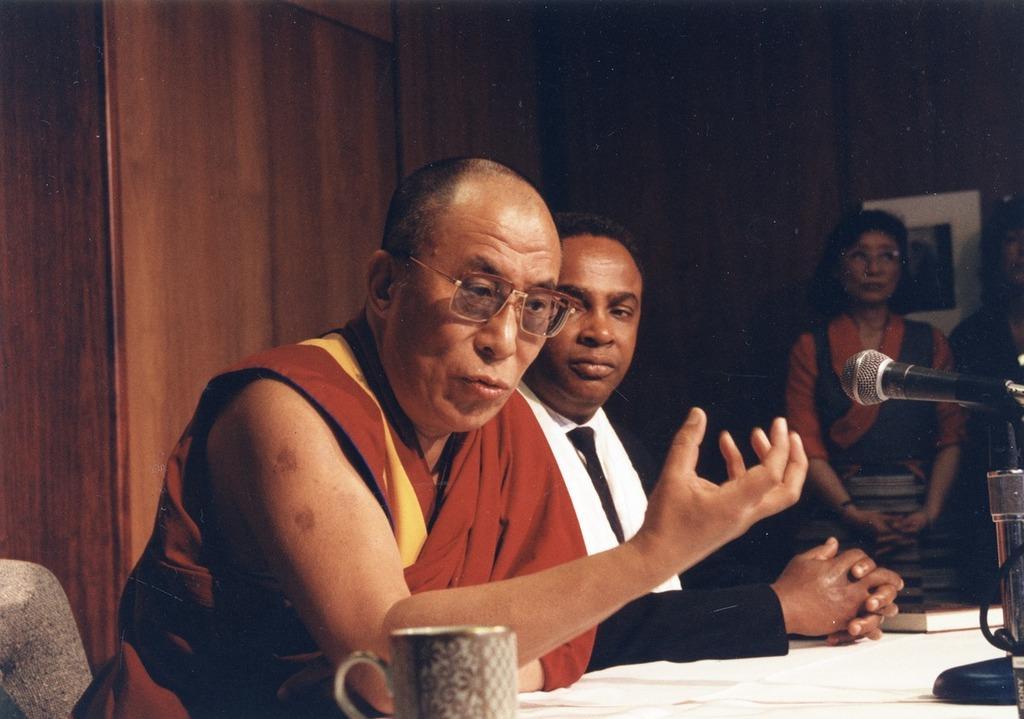Please provide a concise description of this image. In this picture we can see two men sitting on the chair. There is a cup, book and a mic on a white surface. We can see two women standing on the right side. There is a frame on a wooden background. 